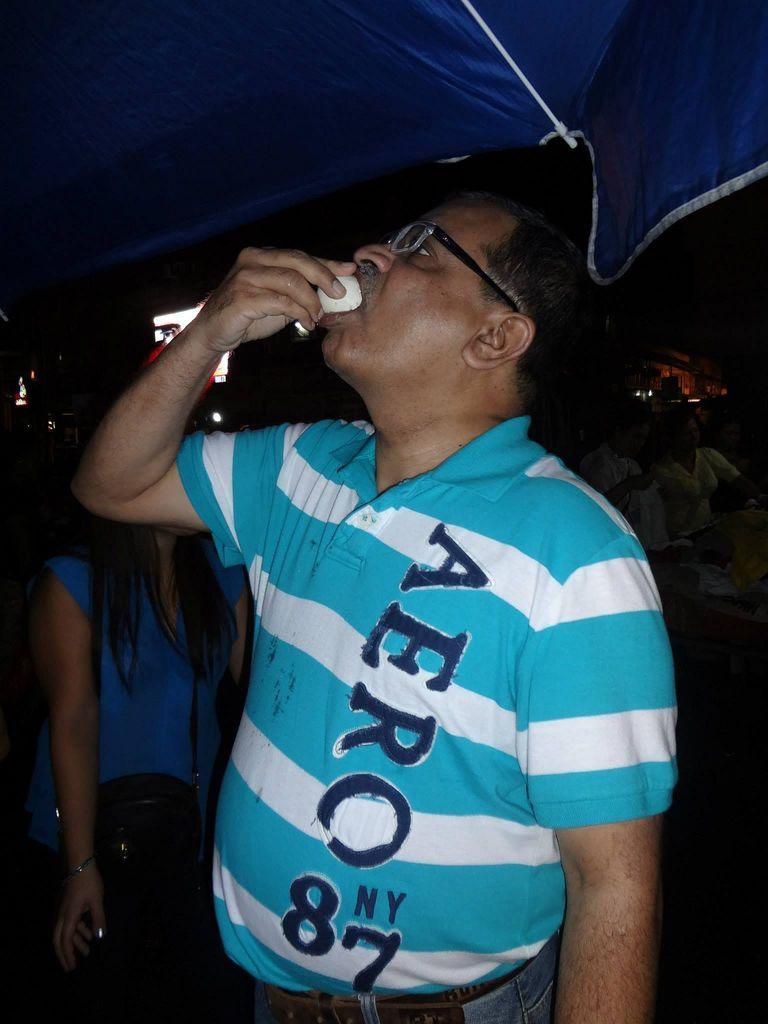How would you summarize this image in a sentence or two? In the foreground of the picture we can see a person eating something. At the top it is looking like an umbrella. In the middle of the picture there are people. In the background there are trees, light and other objects. 